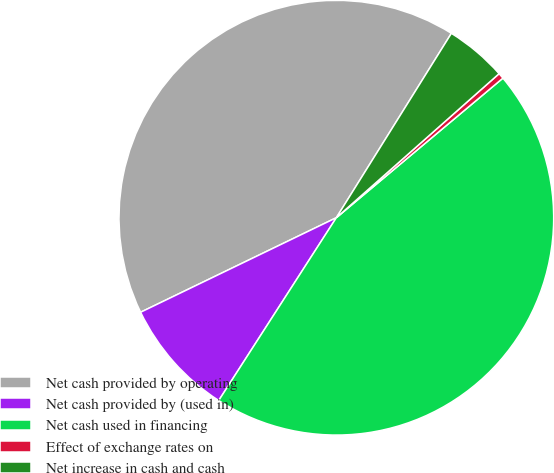<chart> <loc_0><loc_0><loc_500><loc_500><pie_chart><fcel>Net cash provided by operating<fcel>Net cash provided by (used in)<fcel>Net cash used in financing<fcel>Effect of exchange rates on<fcel>Net increase in cash and cash<nl><fcel>41.04%<fcel>8.74%<fcel>45.2%<fcel>0.43%<fcel>4.59%<nl></chart> 